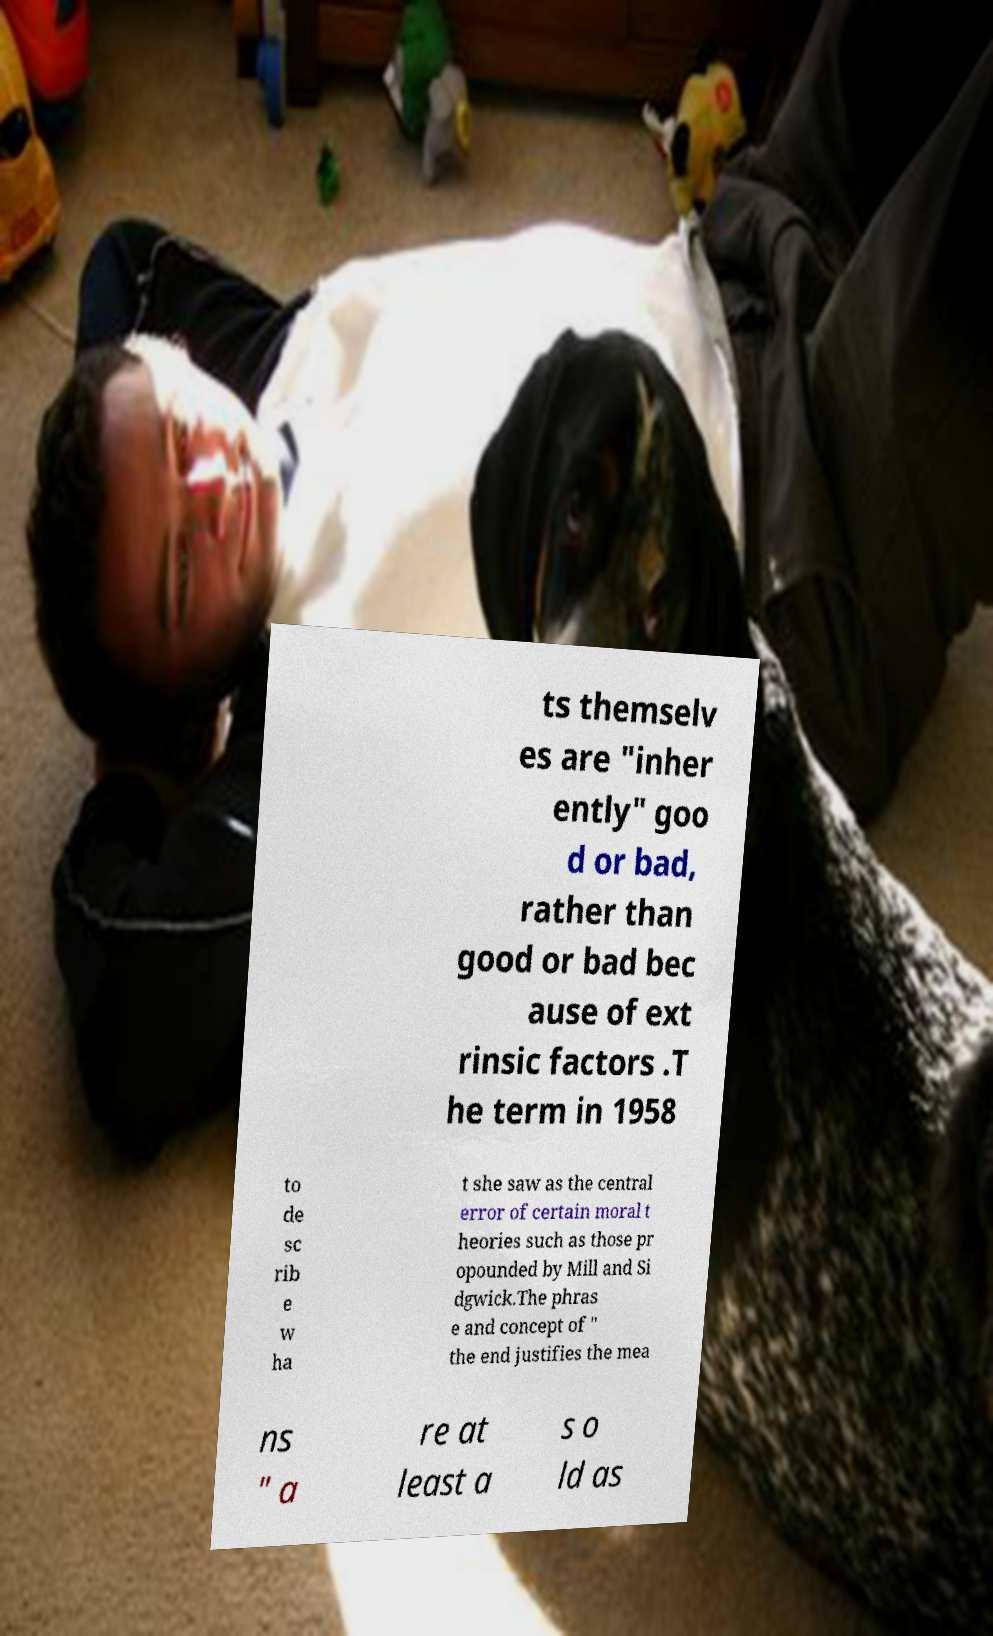Can you read and provide the text displayed in the image?This photo seems to have some interesting text. Can you extract and type it out for me? ts themselv es are "inher ently" goo d or bad, rather than good or bad bec ause of ext rinsic factors .T he term in 1958 to de sc rib e w ha t she saw as the central error of certain moral t heories such as those pr opounded by Mill and Si dgwick.The phras e and concept of " the end justifies the mea ns " a re at least a s o ld as 